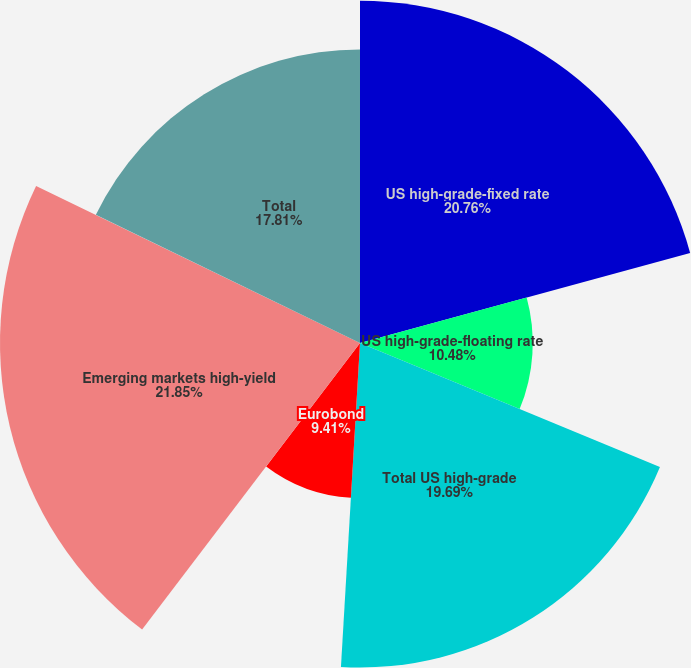Convert chart to OTSL. <chart><loc_0><loc_0><loc_500><loc_500><pie_chart><fcel>US high-grade-fixed rate<fcel>US high-grade-floating rate<fcel>Total US high-grade<fcel>Eurobond<fcel>Emerging markets high-yield<fcel>Total<nl><fcel>20.76%<fcel>10.48%<fcel>19.69%<fcel>9.41%<fcel>21.84%<fcel>17.81%<nl></chart> 